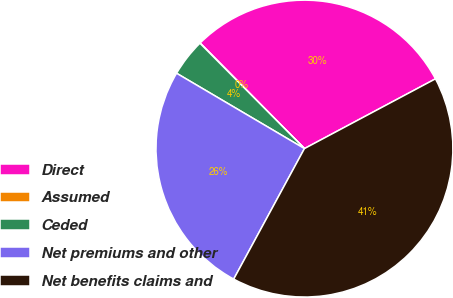<chart> <loc_0><loc_0><loc_500><loc_500><pie_chart><fcel>Direct<fcel>Assumed<fcel>Ceded<fcel>Net premiums and other<fcel>Net benefits claims and<nl><fcel>29.63%<fcel>0.02%<fcel>4.09%<fcel>25.57%<fcel>40.69%<nl></chart> 